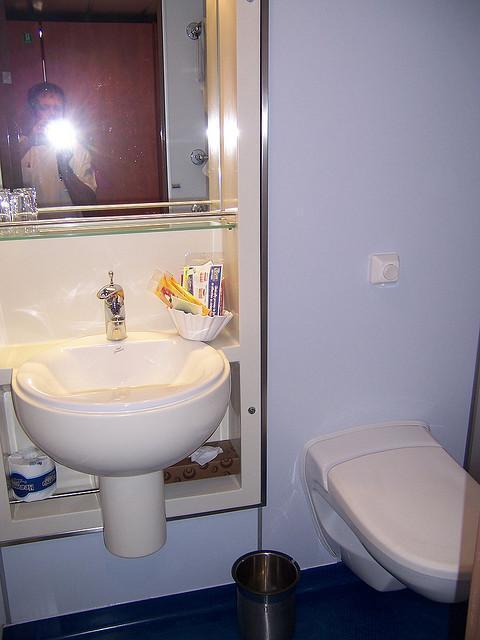How many sinks are in the picture?
Give a very brief answer. 1. 